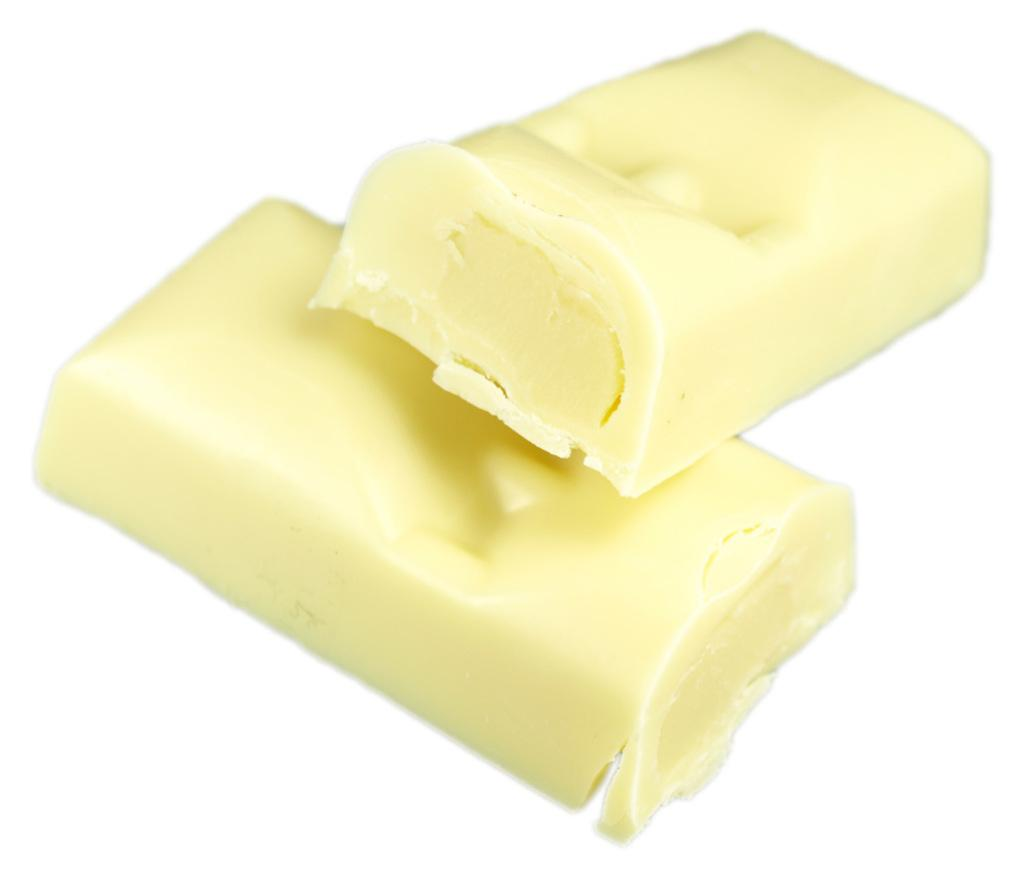What is the main subject of the image? There is a cream-colored food item in the image. What color is the background of the image? The background of the image is white. What type of flower can be seen growing in the sleet in the image? There is no flower or sleet present in the image; it features a cream-colored food item against a white background. 